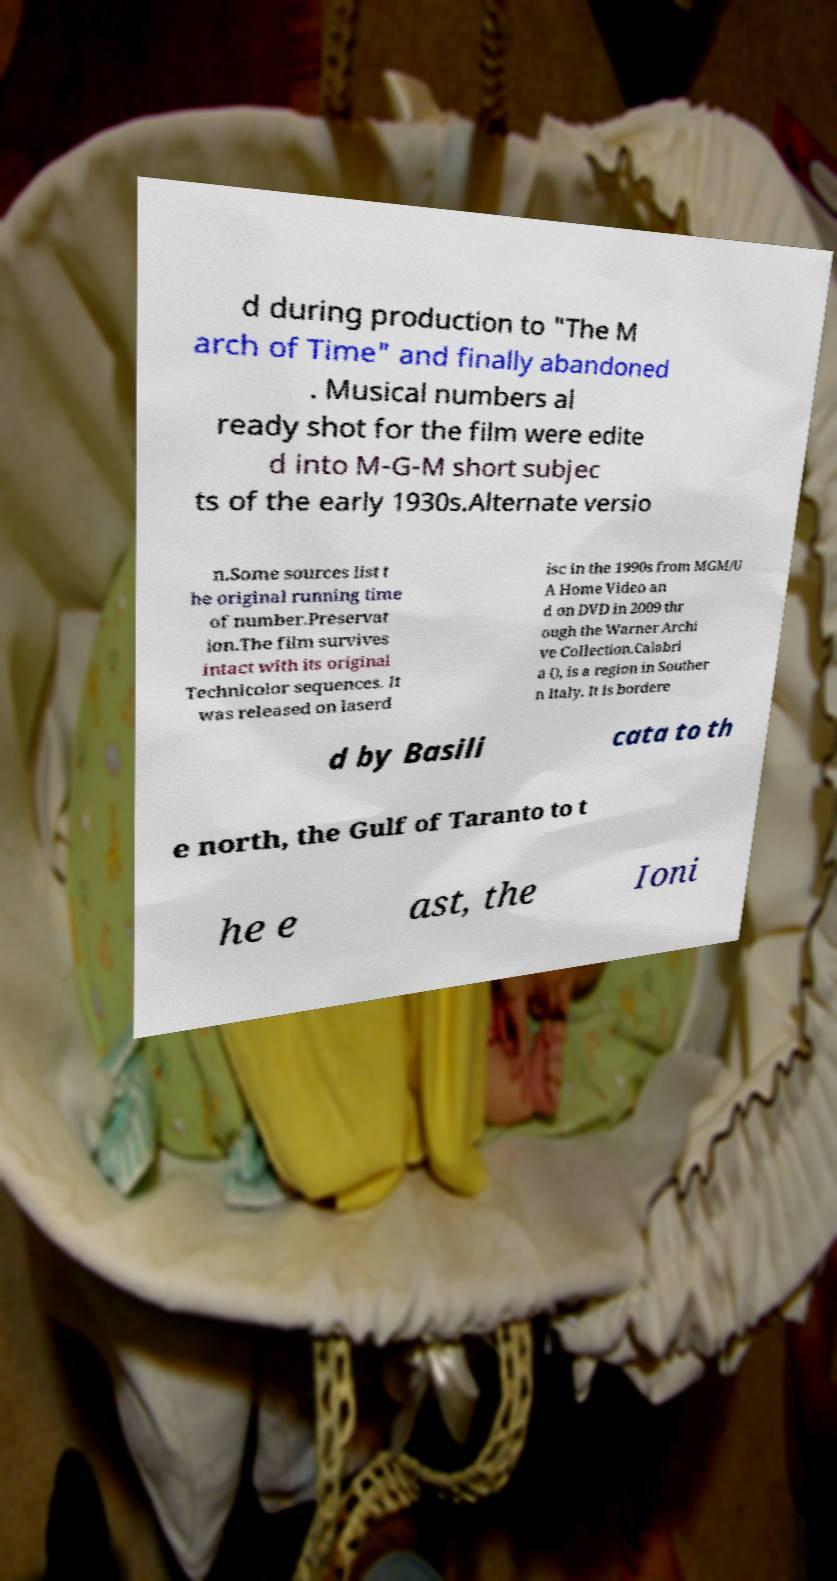There's text embedded in this image that I need extracted. Can you transcribe it verbatim? d during production to "The M arch of Time" and finally abandoned . Musical numbers al ready shot for the film were edite d into M-G-M short subjec ts of the early 1930s.Alternate versio n.Some sources list t he original running time of number.Preservat ion.The film survives intact with its original Technicolor sequences. It was released on laserd isc in the 1990s from MGM/U A Home Video an d on DVD in 2009 thr ough the Warner Archi ve Collection.Calabri a (), is a region in Souther n Italy. It is bordere d by Basili cata to th e north, the Gulf of Taranto to t he e ast, the Ioni 